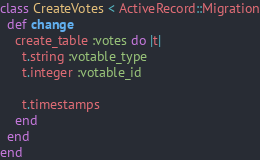Convert code to text. <code><loc_0><loc_0><loc_500><loc_500><_Ruby_>class CreateVotes < ActiveRecord::Migration
  def change
    create_table :votes do |t|
      t.string :votable_type
      t.integer :votable_id

      t.timestamps
    end
  end
end
</code> 